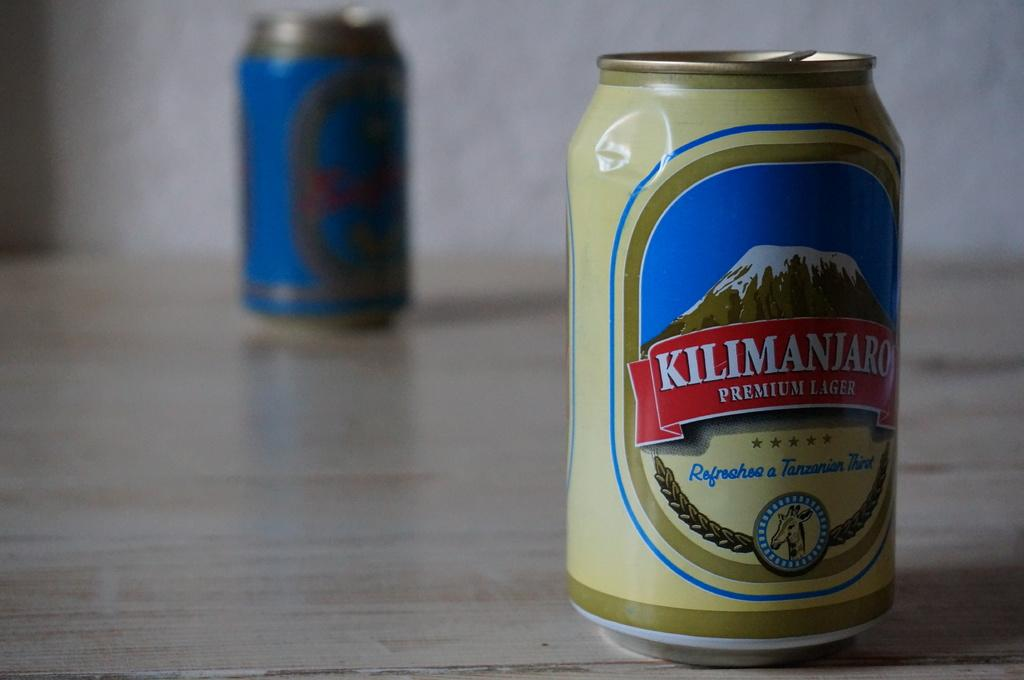<image>
Provide a brief description of the given image. A can of Kilimanjaro lager shows a snow-capped mountain on it. 